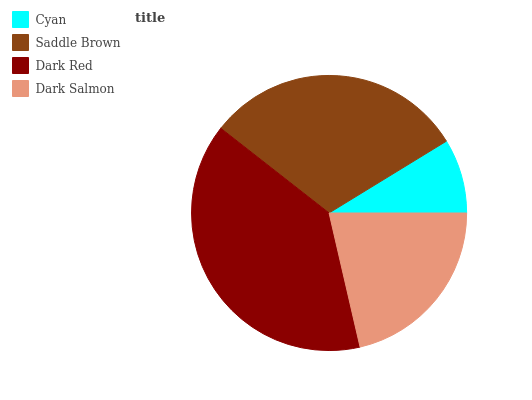Is Cyan the minimum?
Answer yes or no. Yes. Is Dark Red the maximum?
Answer yes or no. Yes. Is Saddle Brown the minimum?
Answer yes or no. No. Is Saddle Brown the maximum?
Answer yes or no. No. Is Saddle Brown greater than Cyan?
Answer yes or no. Yes. Is Cyan less than Saddle Brown?
Answer yes or no. Yes. Is Cyan greater than Saddle Brown?
Answer yes or no. No. Is Saddle Brown less than Cyan?
Answer yes or no. No. Is Saddle Brown the high median?
Answer yes or no. Yes. Is Dark Salmon the low median?
Answer yes or no. Yes. Is Cyan the high median?
Answer yes or no. No. Is Cyan the low median?
Answer yes or no. No. 